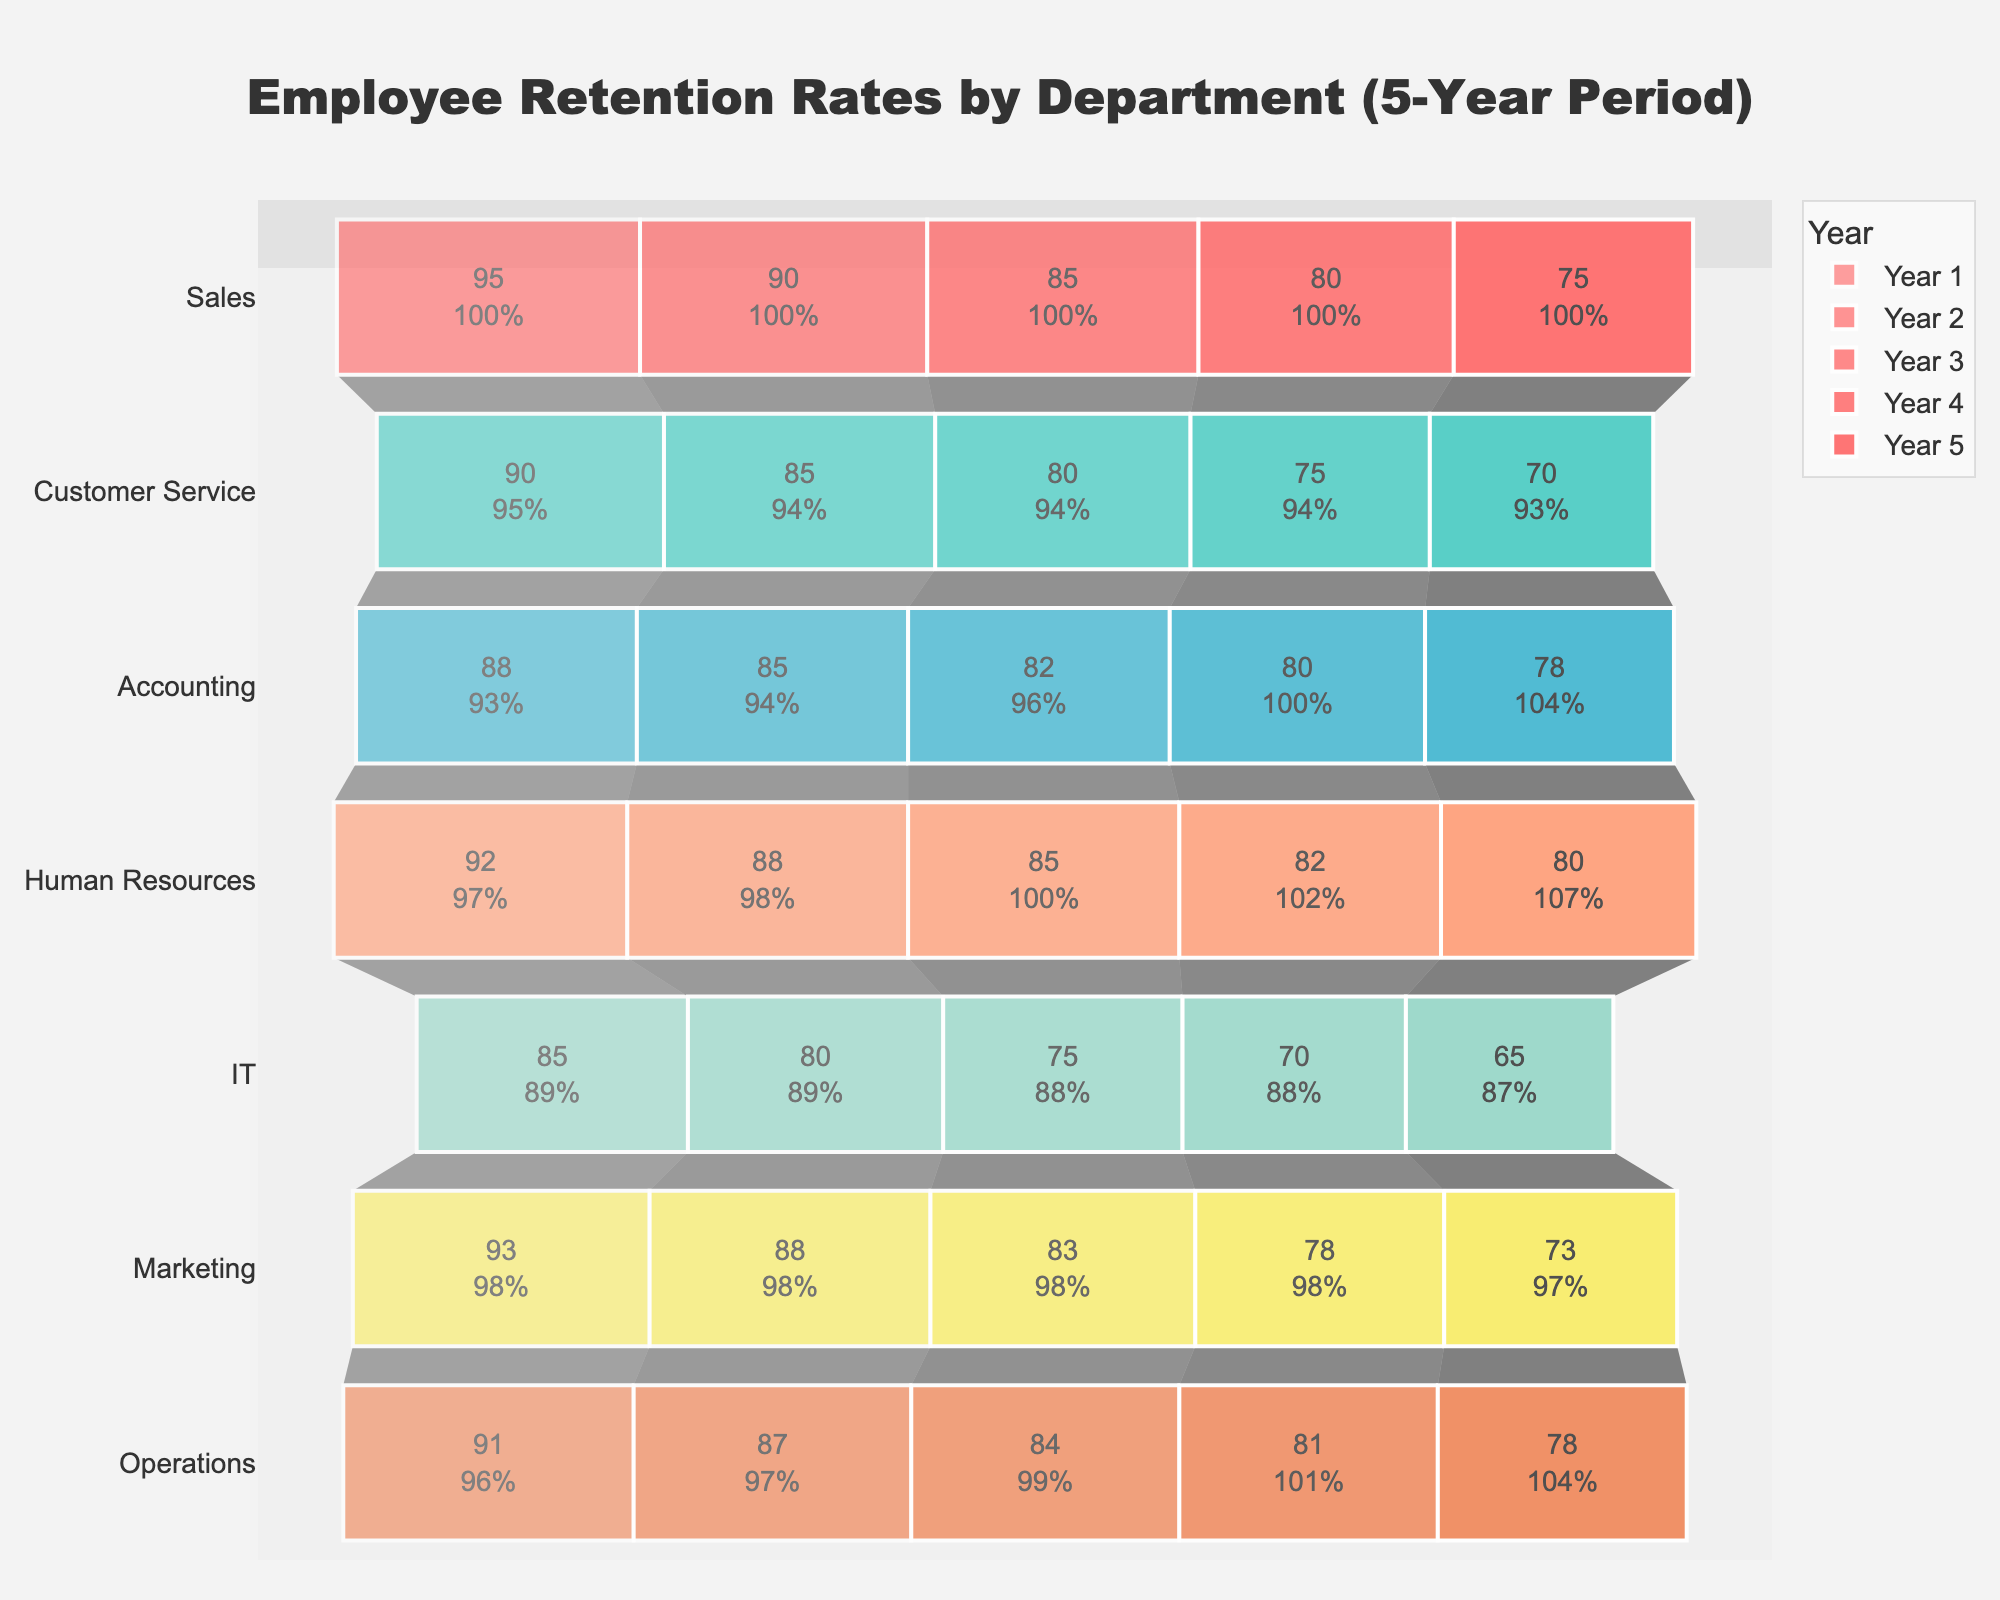What is the title of the chart? The title of the chart is displayed prominently at the top. It reads "Employee Retention Rates by Department (5-Year Period)."
Answer: Employee Retention Rates by Department (5-Year Period) Which department has the highest retention rate in Year 1? To determine the highest retention rate in Year 1, compare the values for Year 1 across all departments. The Sales department has the highest retention rate at 95%.
Answer: Sales How does the IT department's retention rate change from Year 1 to Year 5? To find this, we look at the retention rates for the IT department across the 5 years: Year 1: 85%, Year 2: 80%, Year 3: 75%, Year 4: 70%, and Year 5: 65%.
Answer: It decreases Which department experienced the least change in retention rate over the 5 years? Calculate the difference between Year 1 and Year 5 retention rates for each department. The Accounting department's rates change from 88% to 78%, a difference of 10%. This is the least change compared to other departments.
Answer: Accounting What is the overall trend in retention rates across all departments over the 5-year period? By observing the shape of the funnel chart, it is apparent that the retention rates for all departments decrease over time.
Answer: Decreasing In which year does Marketing show the largest decline in retention compared to the previous year? Calculate the year-over-year differences for Marketing: (Year 1 to Year 2: 93% to 88% = 5%), (Year 2 to Year 3: 88% to 83% = 5%), (Year 3 to Year 4: 83% to 78% = 5%), (Year 4 to Year 5: 78% to 73% = 5%). The declines are equal (5%) each year.
Answer: Every year equally Which two departments have the closest retention rates in Year 3? Compare the retention rates for all departments in Year 3. Customer Service and Marketing both have 80%, and Sales has 85%. Operations has 84%. The closest rates are between Operations (84%) and Human Resources (85%).
Answer: Operations and Human Resources By what percentage did the Sales department's retention rate decrease from Year 1 to Year 5? Calculate the decrease as follows: [(95 -75) / 95] * 100 = 21.05%
Answer: 21.05% Which department shows a retention rate higher than 70% in Year 5? Look at the retention rates for Year 5 and find departments with values higher than 70%. The departments are Accounting (78%), Human Resources (80%), and Operations (78%).
Answer: Accounting, Human Resources, Operations What is the average retention rate of the Human Resources department over the 5 years? Sum the retention rates of Human Resources from Year 1 to Year 5 and divide by 5: (92 + 88 + 85 + 82 + 80) / 5 = 85.4%
Answer: 85.4% 